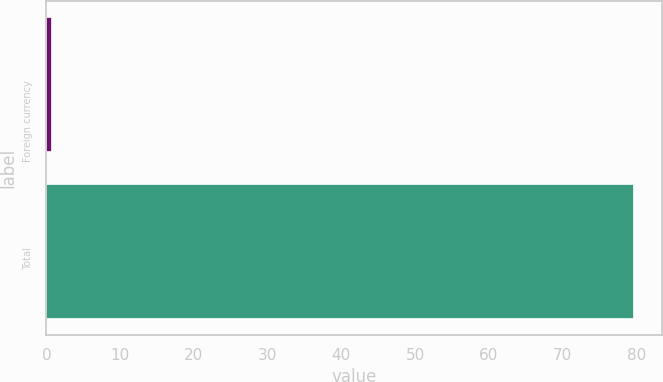<chart> <loc_0><loc_0><loc_500><loc_500><bar_chart><fcel>Foreign currency<fcel>Total<nl><fcel>0.6<fcel>79.5<nl></chart> 